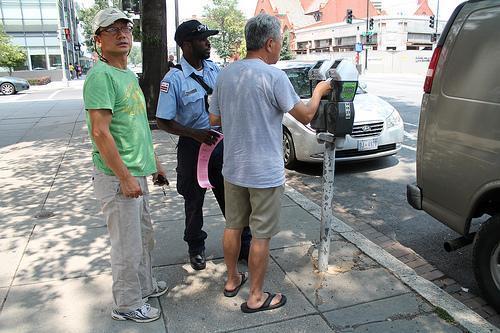How many people was shown?
Give a very brief answer. 3. 